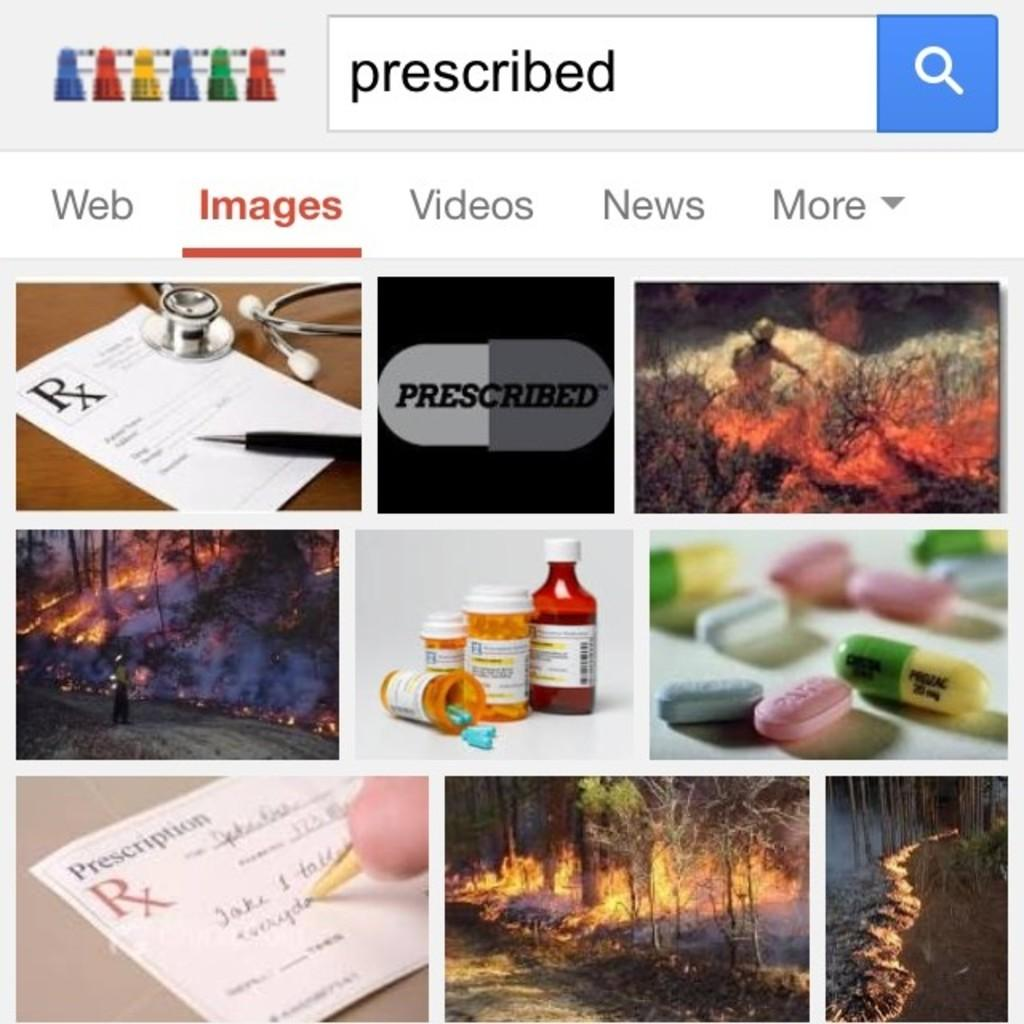What type of icon is present on the page? There is a search icon on the page. How many other icons are on the page besides the search icon? There are multiple other icons on the page. What types of images can be seen on the page? There are images of paper, stethoscope, pen, fire, medicines, bottles, and trees on the page. What type of story is being told through the images on the page? There is no story being told through the images on the page; they are individual icons and images with no narrative connection. 